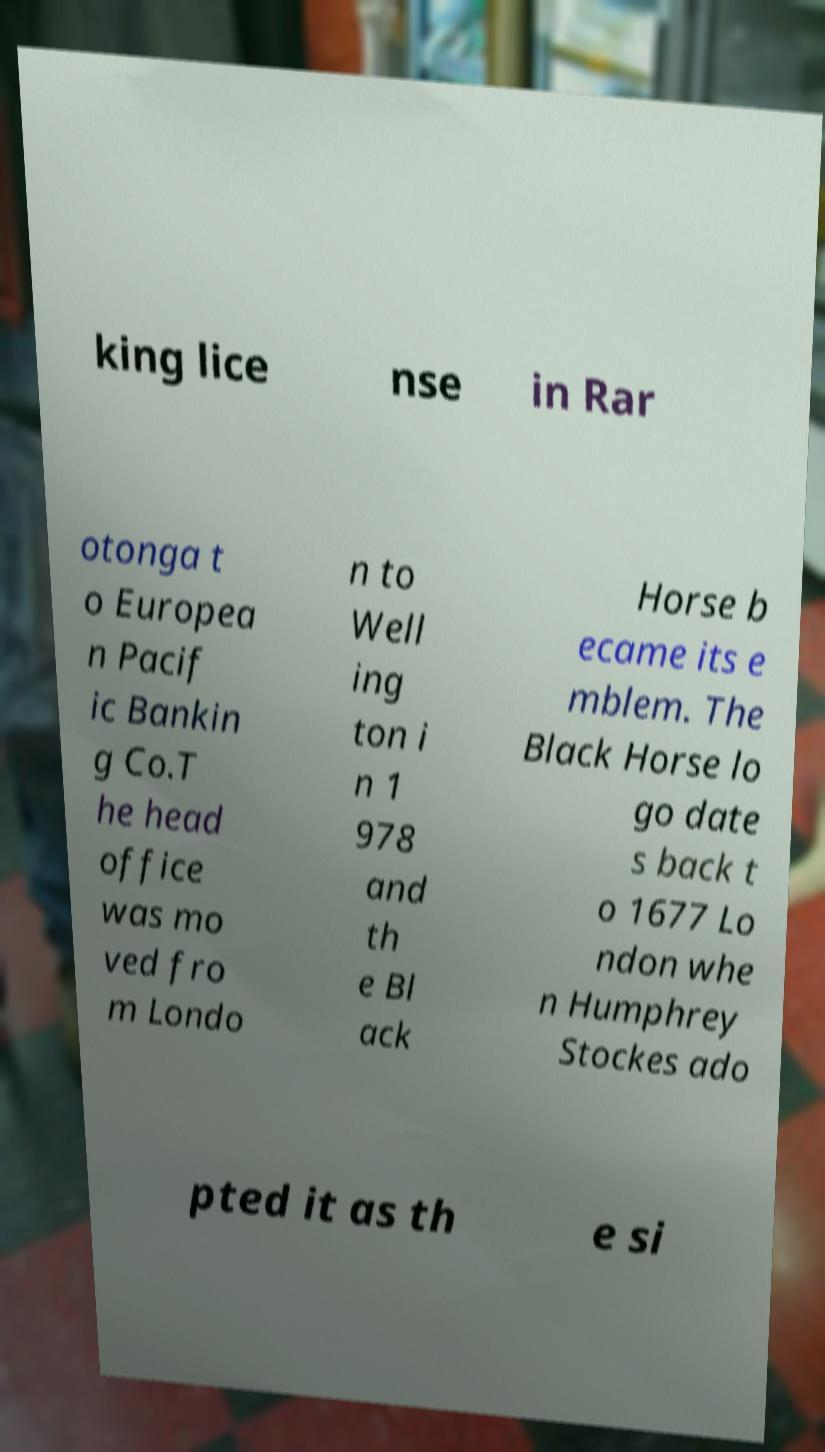Could you extract and type out the text from this image? king lice nse in Rar otonga t o Europea n Pacif ic Bankin g Co.T he head office was mo ved fro m Londo n to Well ing ton i n 1 978 and th e Bl ack Horse b ecame its e mblem. The Black Horse lo go date s back t o 1677 Lo ndon whe n Humphrey Stockes ado pted it as th e si 